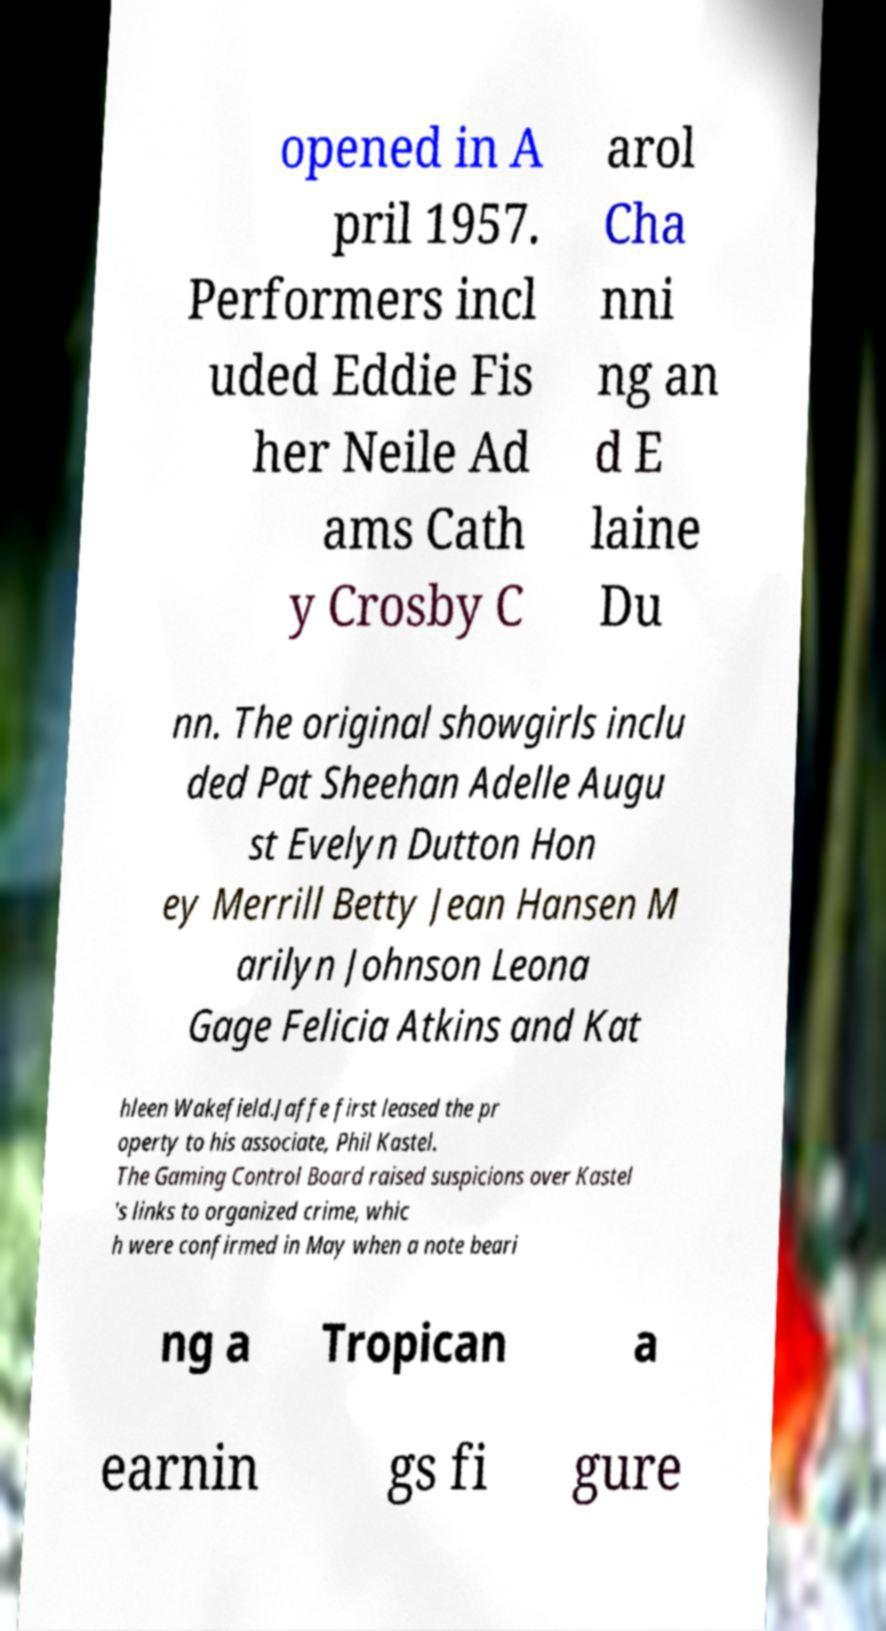Could you extract and type out the text from this image? opened in A pril 1957. Performers incl uded Eddie Fis her Neile Ad ams Cath y Crosby C arol Cha nni ng an d E laine Du nn. The original showgirls inclu ded Pat Sheehan Adelle Augu st Evelyn Dutton Hon ey Merrill Betty Jean Hansen M arilyn Johnson Leona Gage Felicia Atkins and Kat hleen Wakefield.Jaffe first leased the pr operty to his associate, Phil Kastel. The Gaming Control Board raised suspicions over Kastel 's links to organized crime, whic h were confirmed in May when a note beari ng a Tropican a earnin gs fi gure 